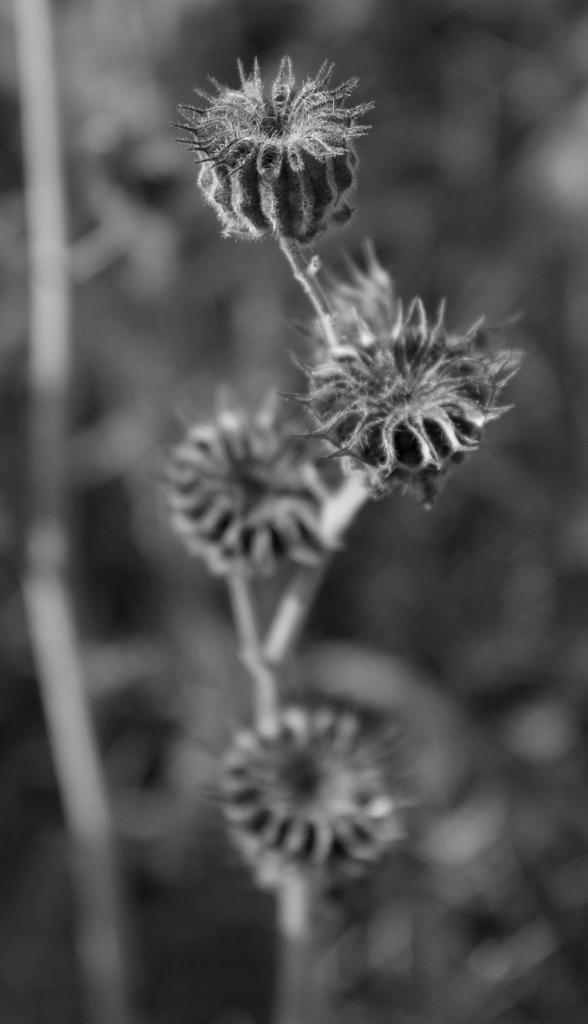Describe this image in one or two sentences. In this image, we can see few flowers with stem. Background there is a blur view. 